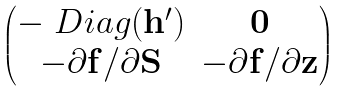Convert formula to latex. <formula><loc_0><loc_0><loc_500><loc_500>\begin{pmatrix} - \ D i a g ( { \mathbf h } ^ { \prime } ) & { \mathbf 0 } \\ - \partial { \mathbf f } / \partial { \mathbf S } & - \partial { \mathbf f } / \partial { \mathbf z } \end{pmatrix}</formula> 